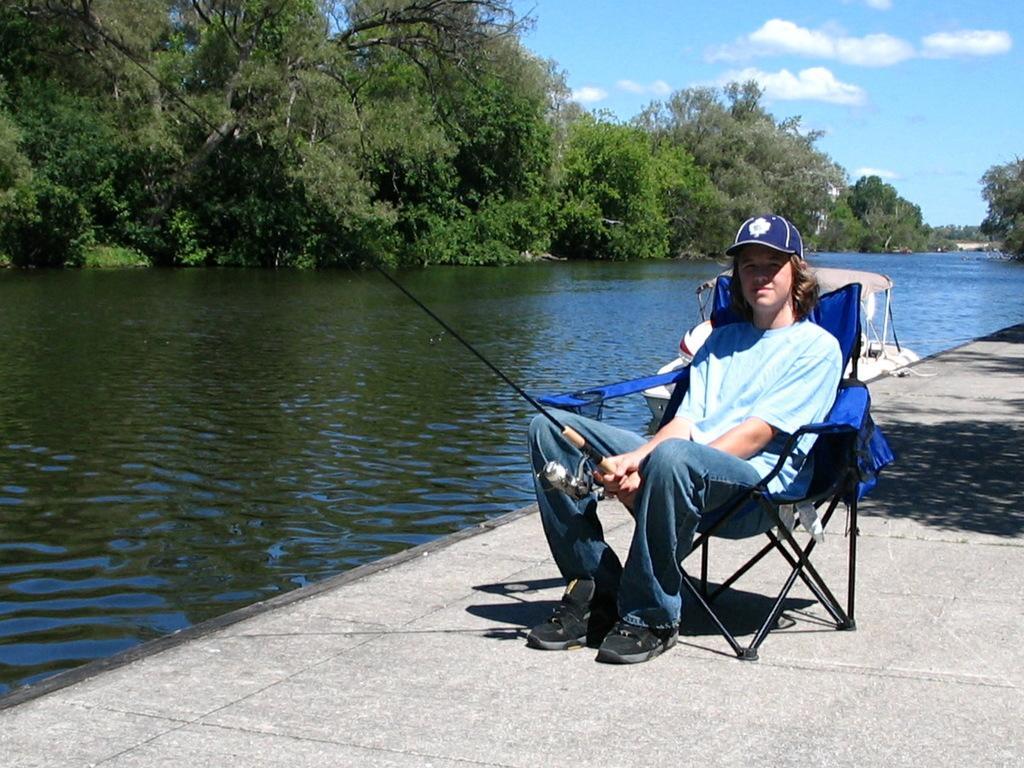Could you give a brief overview of what you see in this image? In this picture I can observe a person sitting on the chair. The person is holding a fishing stick in his hands. In the middle of the picture I can observe a lake. In the background there are trees and some clouds in the sky. 